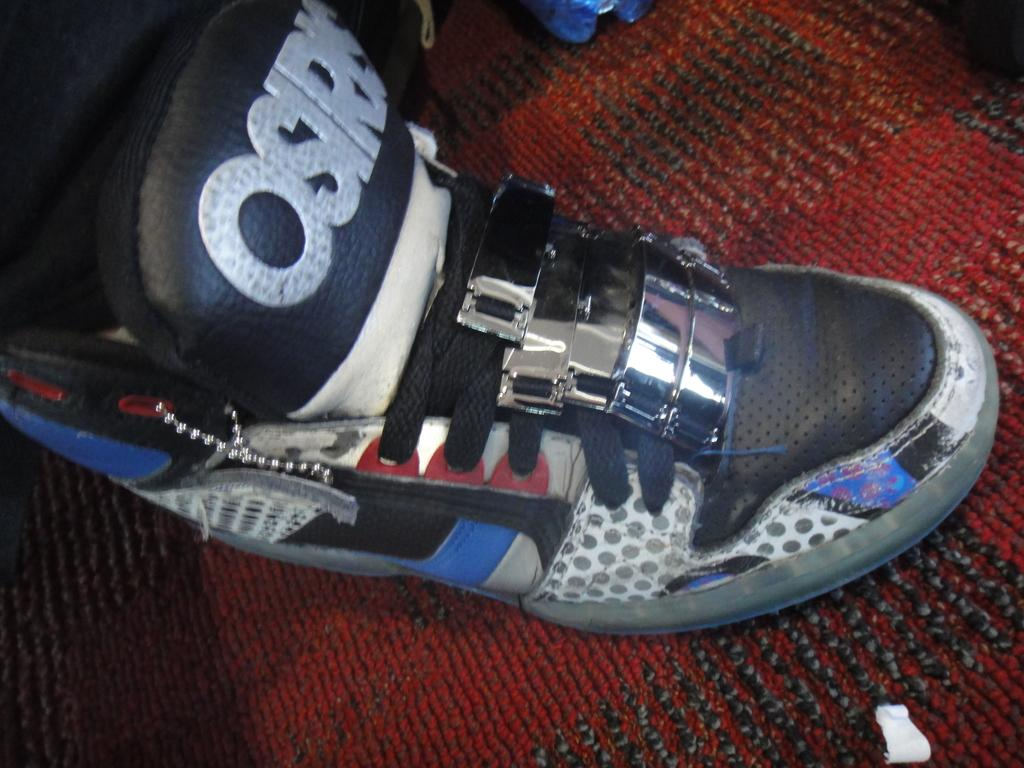Provide a one-sentence caption for the provided image. A person is wearing an Osiris shoe on their right foot. 